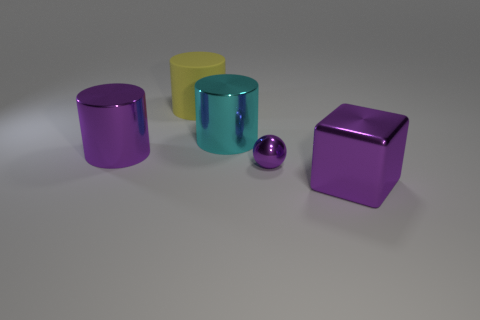Are there any other things that are the same shape as the tiny metal thing?
Your answer should be very brief. No. How many tiny purple objects are there?
Your answer should be compact. 1. What number of other big cylinders are the same material as the cyan cylinder?
Provide a short and direct response. 1. How many things are big metallic things that are left of the tiny purple metal thing or tiny cyan cubes?
Your answer should be very brief. 2. Is the number of cyan cylinders to the left of the yellow cylinder less than the number of tiny spheres in front of the large purple cylinder?
Make the answer very short. Yes. There is a large purple block; are there any large purple blocks right of it?
Ensure brevity in your answer.  No. How many things are either metallic things left of the big purple metallic cube or matte objects to the left of the large cyan metal thing?
Give a very brief answer. 4. How many small objects have the same color as the shiny ball?
Your answer should be very brief. 0. The other metal object that is the same shape as the cyan thing is what color?
Provide a succinct answer. Purple. The purple metallic object that is both on the right side of the matte cylinder and on the left side of the metal block has what shape?
Provide a succinct answer. Sphere. 